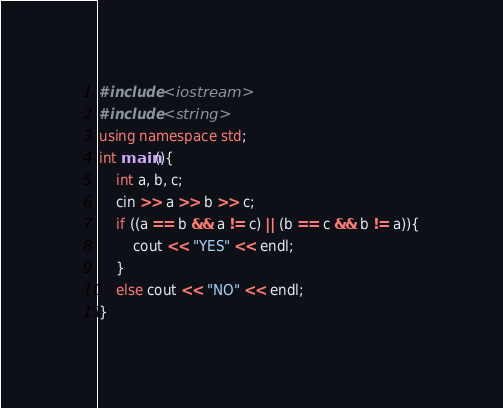<code> <loc_0><loc_0><loc_500><loc_500><_C++_>#include <iostream>
#include <string>
using namespace std;
int main(){
    int a, b, c;
    cin >> a >> b >> c;
    if ((a == b && a != c) || (b == c && b != a)){
        cout << "YES" << endl;
    }
    else cout << "NO" << endl;
}</code> 